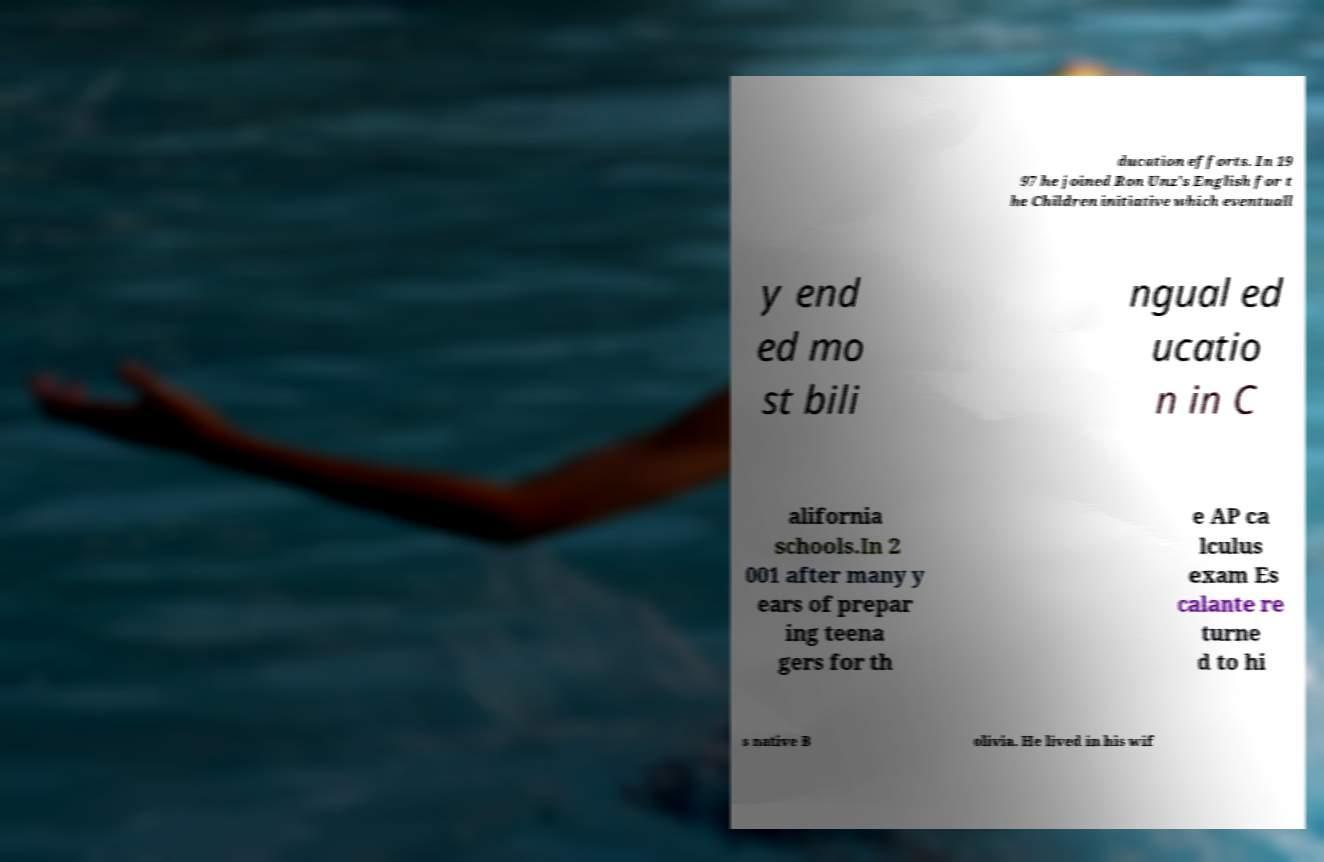Could you assist in decoding the text presented in this image and type it out clearly? ducation efforts. In 19 97 he joined Ron Unz's English for t he Children initiative which eventuall y end ed mo st bili ngual ed ucatio n in C alifornia schools.In 2 001 after many y ears of prepar ing teena gers for th e AP ca lculus exam Es calante re turne d to hi s native B olivia. He lived in his wif 